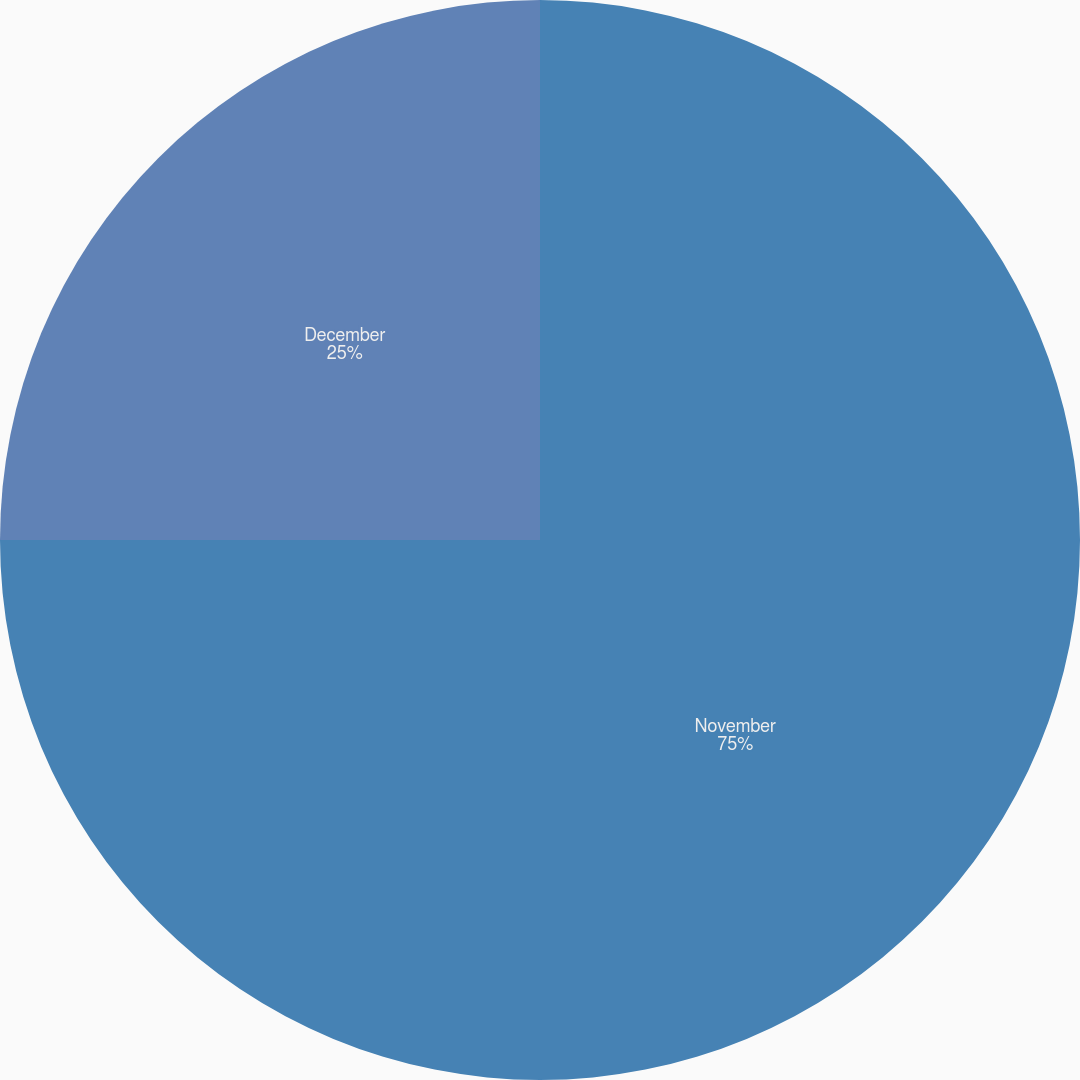Convert chart. <chart><loc_0><loc_0><loc_500><loc_500><pie_chart><fcel>November<fcel>December<nl><fcel>75.0%<fcel>25.0%<nl></chart> 